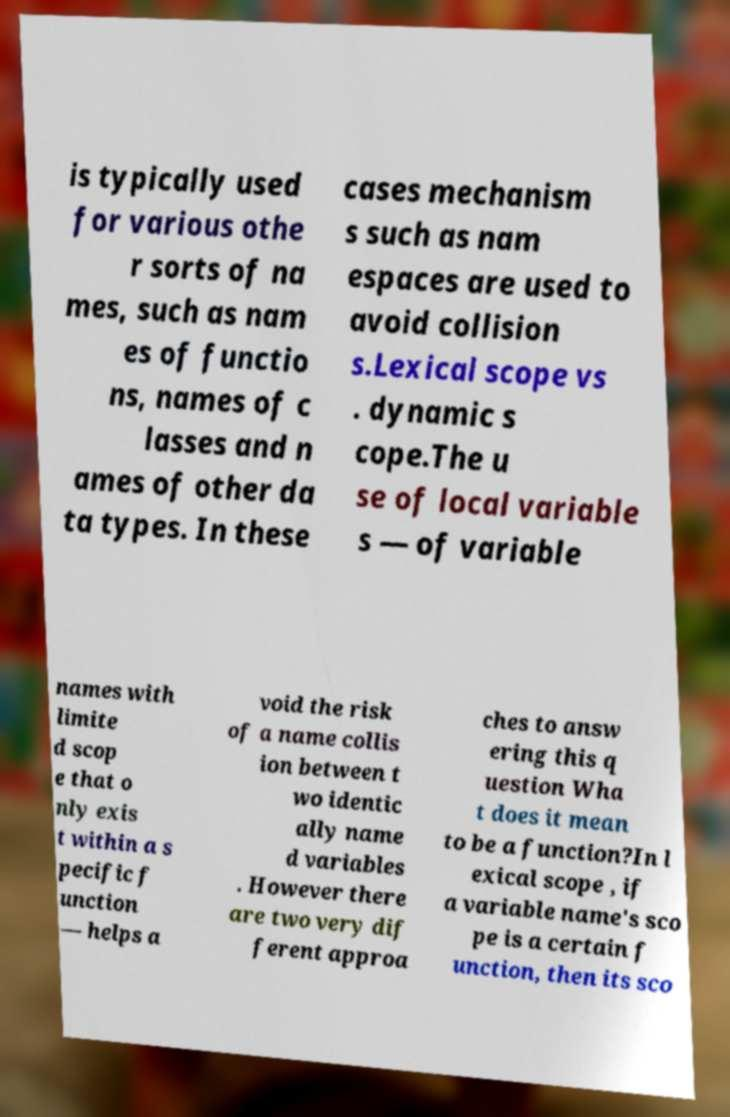There's text embedded in this image that I need extracted. Can you transcribe it verbatim? is typically used for various othe r sorts of na mes, such as nam es of functio ns, names of c lasses and n ames of other da ta types. In these cases mechanism s such as nam espaces are used to avoid collision s.Lexical scope vs . dynamic s cope.The u se of local variable s — of variable names with limite d scop e that o nly exis t within a s pecific f unction — helps a void the risk of a name collis ion between t wo identic ally name d variables . However there are two very dif ferent approa ches to answ ering this q uestion Wha t does it mean to be a function?In l exical scope , if a variable name's sco pe is a certain f unction, then its sco 